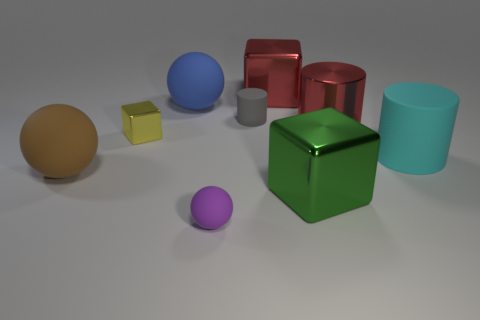Subtract all metallic cylinders. How many cylinders are left? 2 Add 1 tiny blue metallic spheres. How many objects exist? 10 Subtract all balls. How many objects are left? 6 Subtract all gray spheres. Subtract all blue blocks. How many spheres are left? 3 Add 4 tiny purple balls. How many tiny purple balls exist? 5 Subtract 1 brown balls. How many objects are left? 8 Subtract all large gray shiny cylinders. Subtract all red things. How many objects are left? 7 Add 6 small yellow objects. How many small yellow objects are left? 7 